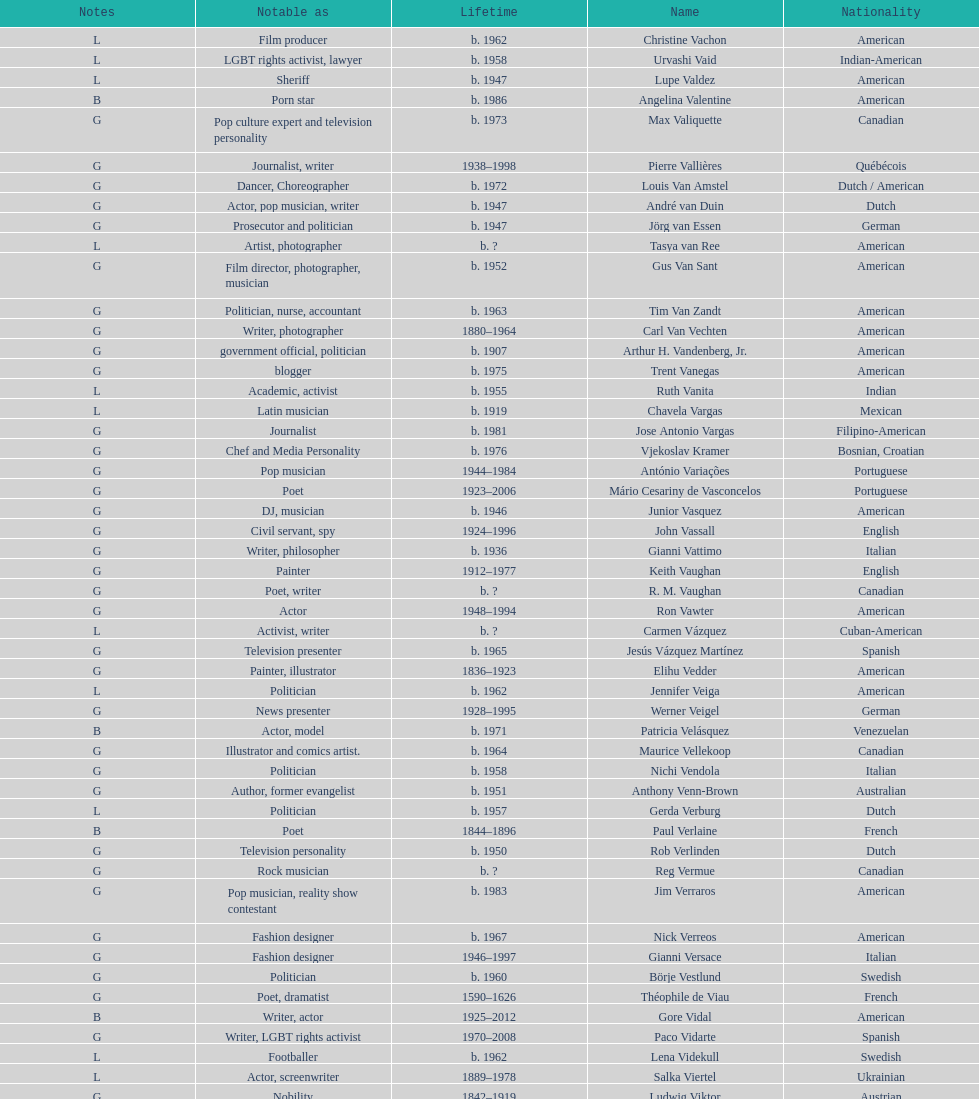Which nationality had the most notable poets? French. 